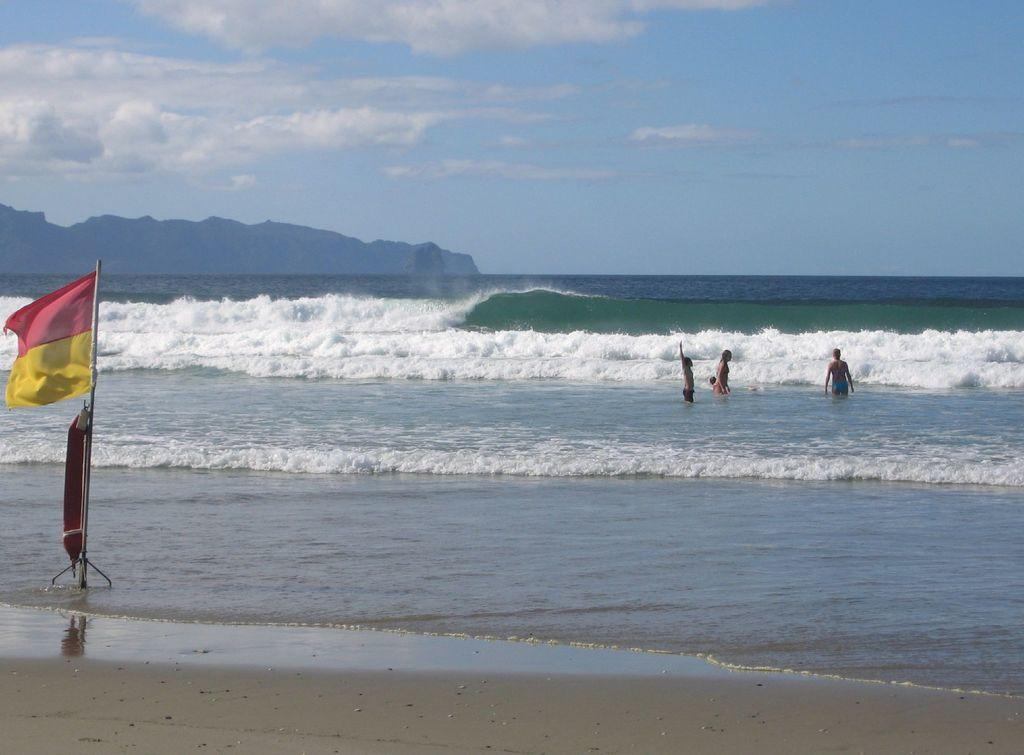Please provide a concise description of this image. This picture is clicked outside. On the left we can see a flag and an object attached to the metal rod. In the center we can see the group of persons and the ripples in the water body. In the background we can see the sky, clouds, hills and some other objects. 